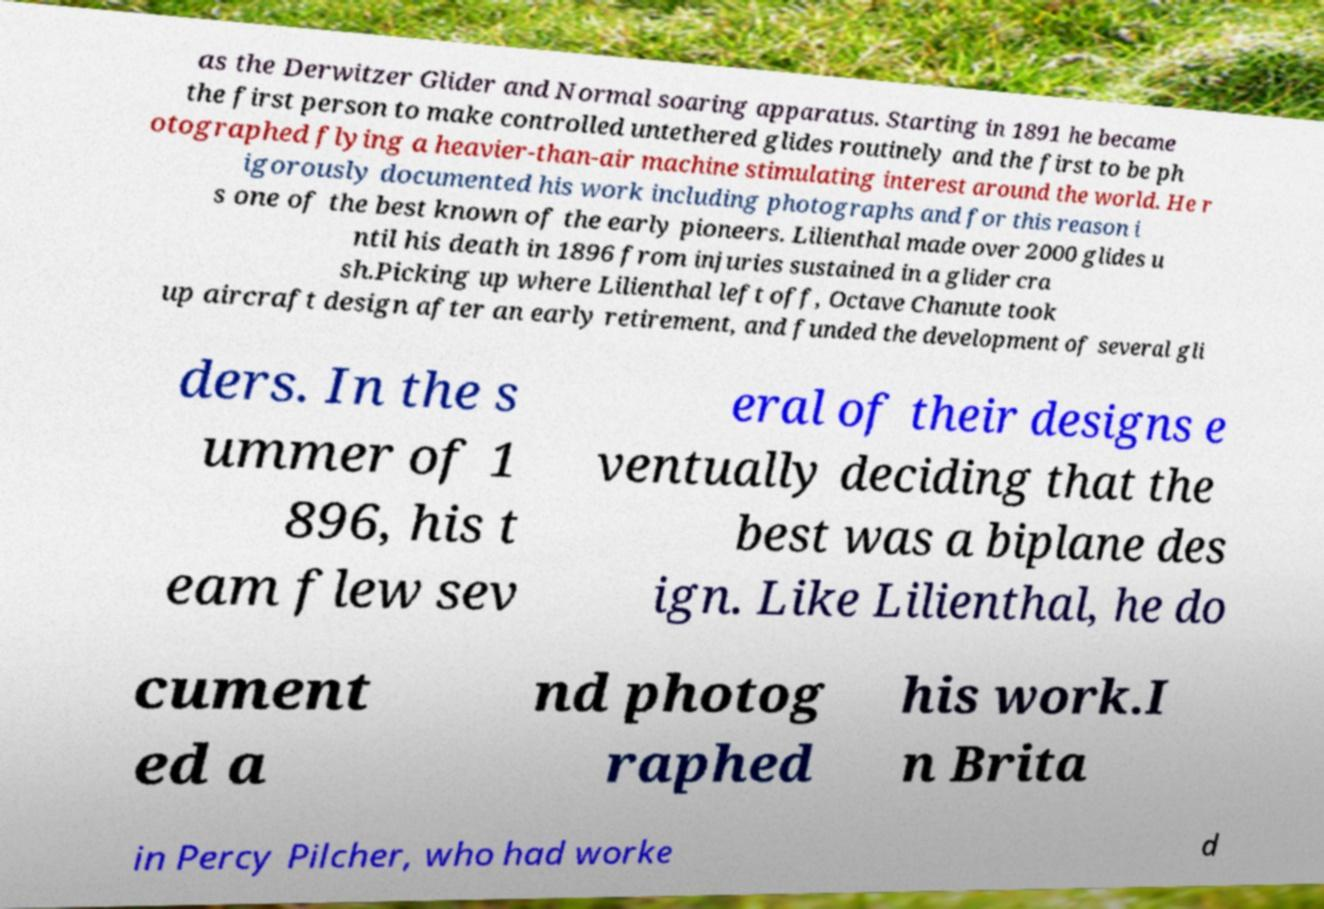Could you extract and type out the text from this image? as the Derwitzer Glider and Normal soaring apparatus. Starting in 1891 he became the first person to make controlled untethered glides routinely and the first to be ph otographed flying a heavier-than-air machine stimulating interest around the world. He r igorously documented his work including photographs and for this reason i s one of the best known of the early pioneers. Lilienthal made over 2000 glides u ntil his death in 1896 from injuries sustained in a glider cra sh.Picking up where Lilienthal left off, Octave Chanute took up aircraft design after an early retirement, and funded the development of several gli ders. In the s ummer of 1 896, his t eam flew sev eral of their designs e ventually deciding that the best was a biplane des ign. Like Lilienthal, he do cument ed a nd photog raphed his work.I n Brita in Percy Pilcher, who had worke d 